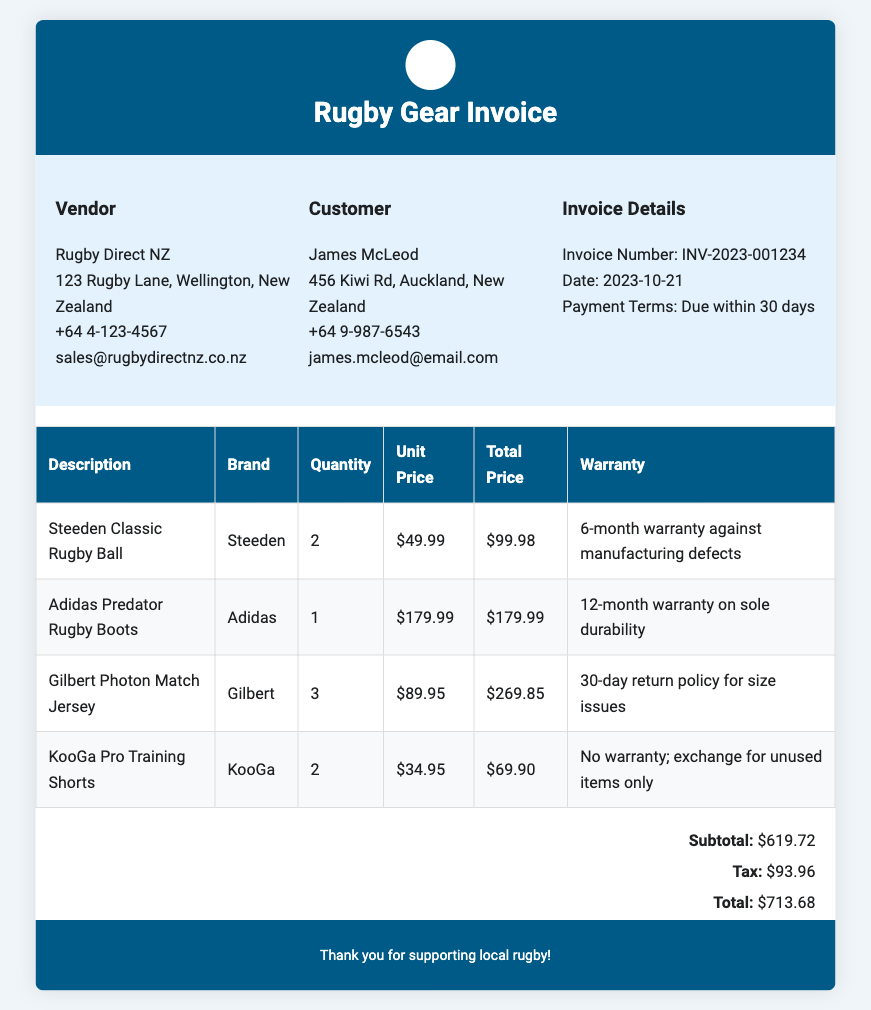What is the invoice number? The invoice number is clearly specified under the Invoice Details section in the document.
Answer: INV-2023-001234 Who is the vendor? The vendor details are listed in the invoice, including the name and contact information.
Answer: Rugby Direct NZ What is the total price? The total price is the final amount calculated after subtotal and tax, mentioned in the invoice summary.
Answer: $713.68 How many Adidas Predator Rugby Boots were purchased? The quantity of Adidas Predator Rugby Boots is given in the itemized section of the document.
Answer: 1 What warranty is provided for the KooGa Pro Training Shorts? The warranty information for the KooGa Pro Training Shorts is mentioned in the description section for that item.
Answer: No warranty; exchange for unused items only What is the subtotal amount before tax? The subtotal is the sum of all itemized prices before adding tax, as specified in the invoice summary.
Answer: $619.72 What is the quantity of Gilbert Photon Match Jerseys? The quantity of Gilbert Photon Match Jerseys is listed in the invoice table under the respective item.
Answer: 3 What date was the invoice issued? The date of the invoice is recorded in the Invoice Details section of the document.
Answer: 2023-10-21 What is the brand of the rugby ball listed? The brand of the rugby ball is detailed in the itemized costs section of the invoice.
Answer: Steeden 